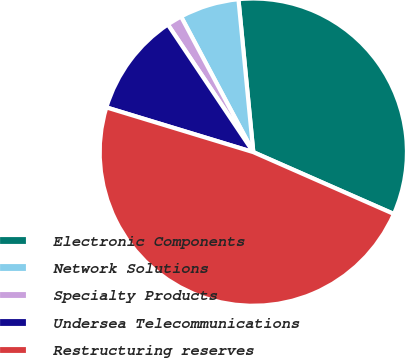Convert chart to OTSL. <chart><loc_0><loc_0><loc_500><loc_500><pie_chart><fcel>Electronic Components<fcel>Network Solutions<fcel>Specialty Products<fcel>Undersea Telecommunications<fcel>Restructuring reserves<nl><fcel>33.14%<fcel>6.25%<fcel>1.6%<fcel>10.9%<fcel>48.1%<nl></chart> 